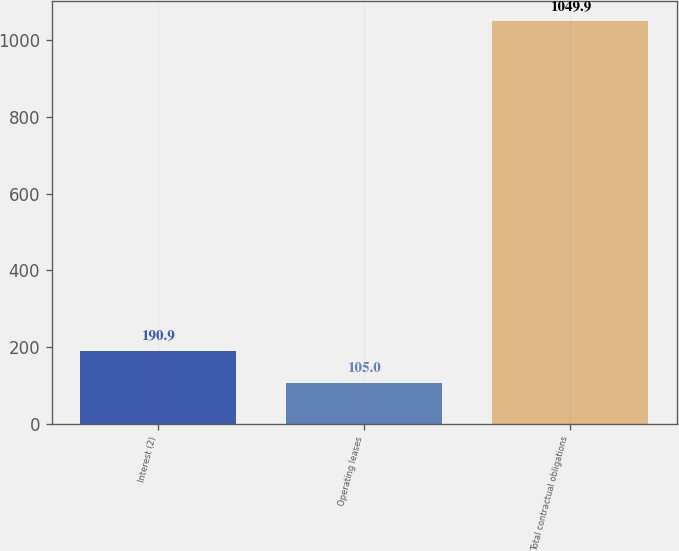Convert chart to OTSL. <chart><loc_0><loc_0><loc_500><loc_500><bar_chart><fcel>Interest (2)<fcel>Operating leases<fcel>Total contractual obligations<nl><fcel>190.9<fcel>105<fcel>1049.9<nl></chart> 